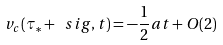Convert formula to latex. <formula><loc_0><loc_0><loc_500><loc_500>v _ { c } ( \tau _ { * } + \ s i g , t ) = - \frac { 1 } { 2 } a t + O ( 2 )</formula> 